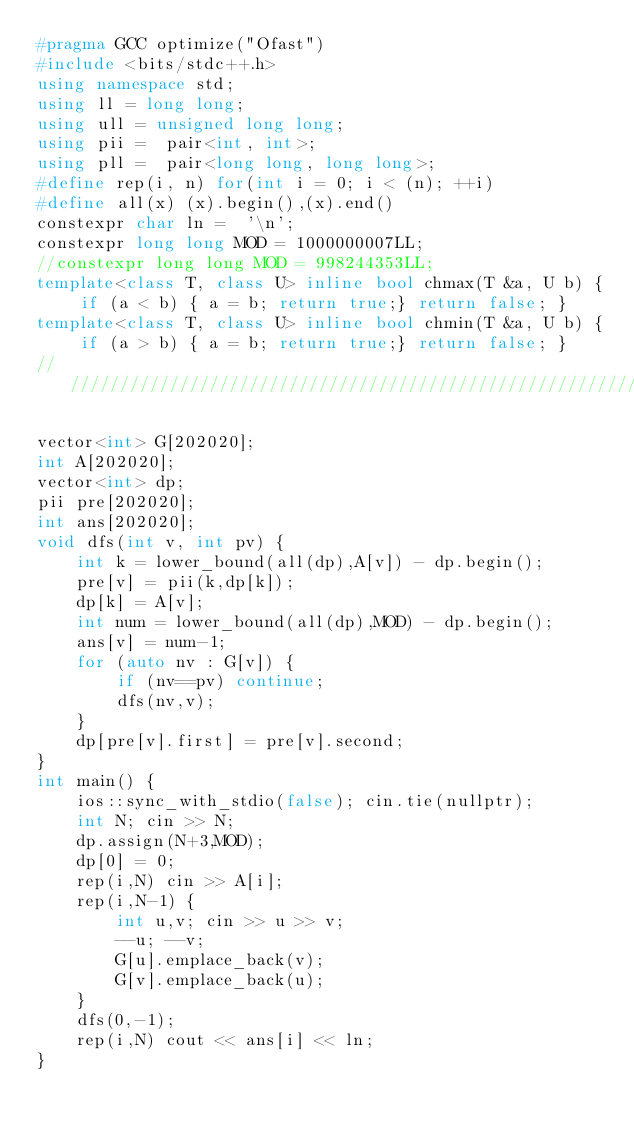Convert code to text. <code><loc_0><loc_0><loc_500><loc_500><_C++_>#pragma GCC optimize("Ofast")
#include <bits/stdc++.h>
using namespace std;
using ll = long long;
using ull = unsigned long long; 
using pii =  pair<int, int>;
using pll =  pair<long long, long long>;
#define rep(i, n) for(int i = 0; i < (n); ++i)
#define all(x) (x).begin(),(x).end()
constexpr char ln =  '\n';
constexpr long long MOD = 1000000007LL;
//constexpr long long MOD = 998244353LL;
template<class T, class U> inline bool chmax(T &a, U b) { if (a < b) { a = b; return true;} return false; }
template<class T, class U> inline bool chmin(T &a, U b) { if (a > b) { a = b; return true;} return false; }
////////////////////////////////////////////////////////////////////////////////////////////////////////////////////////

vector<int> G[202020];
int A[202020];
vector<int> dp;
pii pre[202020];
int ans[202020];
void dfs(int v, int pv) {
    int k = lower_bound(all(dp),A[v]) - dp.begin();
    pre[v] = pii(k,dp[k]);
    dp[k] = A[v];
    int num = lower_bound(all(dp),MOD) - dp.begin();
    ans[v] = num-1;
    for (auto nv : G[v]) {
        if (nv==pv) continue;
        dfs(nv,v);
    }
    dp[pre[v].first] = pre[v].second;
}
int main() {
    ios::sync_with_stdio(false); cin.tie(nullptr);
    int N; cin >> N;
    dp.assign(N+3,MOD);
    dp[0] = 0;
    rep(i,N) cin >> A[i];
    rep(i,N-1) {
        int u,v; cin >> u >> v;
        --u; --v;
        G[u].emplace_back(v);
        G[v].emplace_back(u);
    }
    dfs(0,-1);
    rep(i,N) cout << ans[i] << ln;
}


</code> 